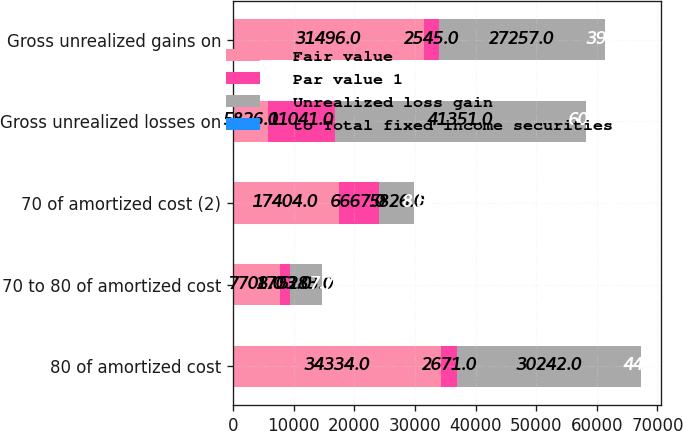<chart> <loc_0><loc_0><loc_500><loc_500><stacked_bar_chart><ecel><fcel>80 of amortized cost<fcel>70 to 80 of amortized cost<fcel>70 of amortized cost (2)<fcel>Gross unrealized losses on<fcel>Gross unrealized gains on<nl><fcel>Fair value<fcel>34334<fcel>7708<fcel>17404<fcel>5826<fcel>31496<nl><fcel>Par value 1<fcel>2671<fcel>1703<fcel>6667<fcel>11041<fcel>2545<nl><fcel>Unrealized loss gain<fcel>30242<fcel>5283<fcel>5826<fcel>41351<fcel>27257<nl><fcel>to Total fixed income securities<fcel>44.1<fcel>7.7<fcel>8.5<fcel>60.3<fcel>39.7<nl></chart> 